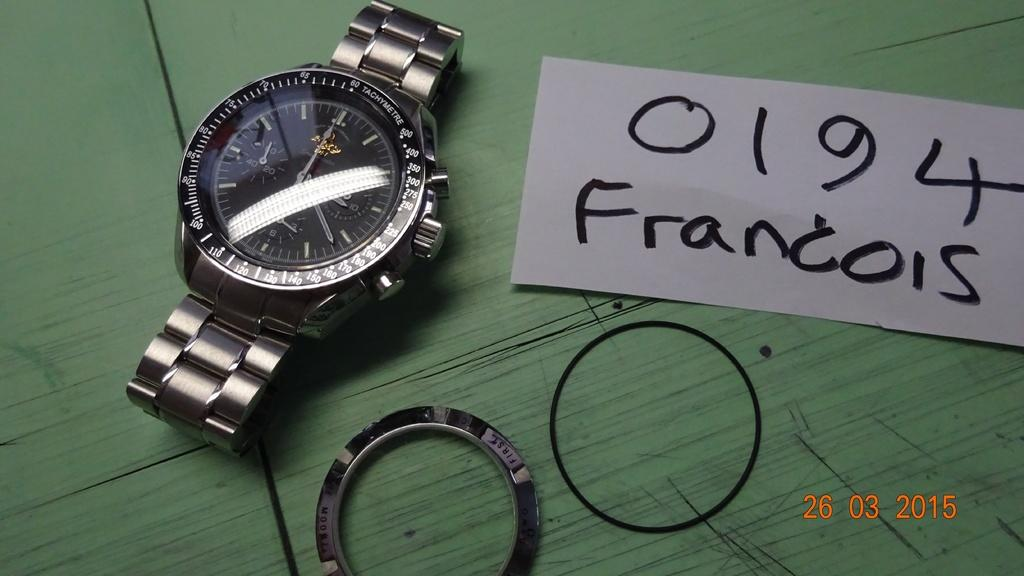<image>
Create a compact narrative representing the image presented. A watch is on display, with a notecard reading "0194 Francois" next to it. 